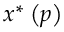Convert formula to latex. <formula><loc_0><loc_0><loc_500><loc_500>x ^ { \ast } \left ( p \right )</formula> 